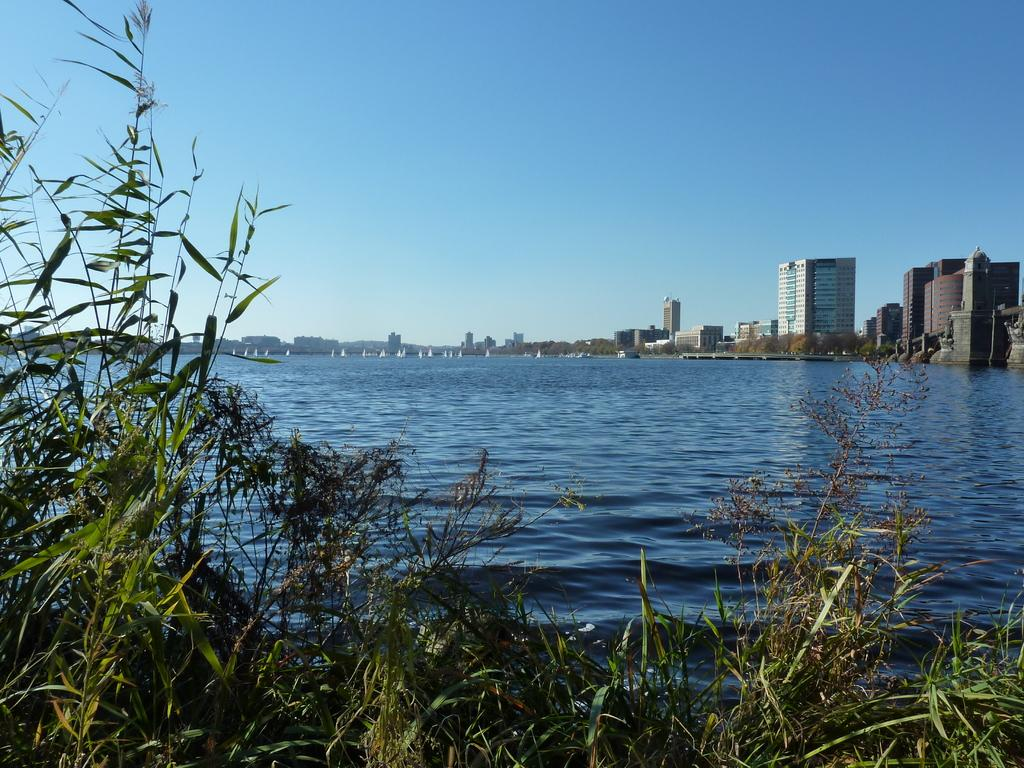What is the primary element visible in the image? There is water in the image. What can be seen at the bottom of the image? There are plants at the bottom of the image. What type of structures are visible in the background of the image? There are buildings in the background of the image. What other natural elements can be seen in the background of the image? There are trees in the background of the image. What is visible at the top of the image? The sky is visible at the top of the image. Are there any signs of a volcano erupting in the image? There is no indication of a volcano or any volcanic activity in the image. Can you see any giants walking through the water in the image? There are no giants or any human-like figures present in the image. 